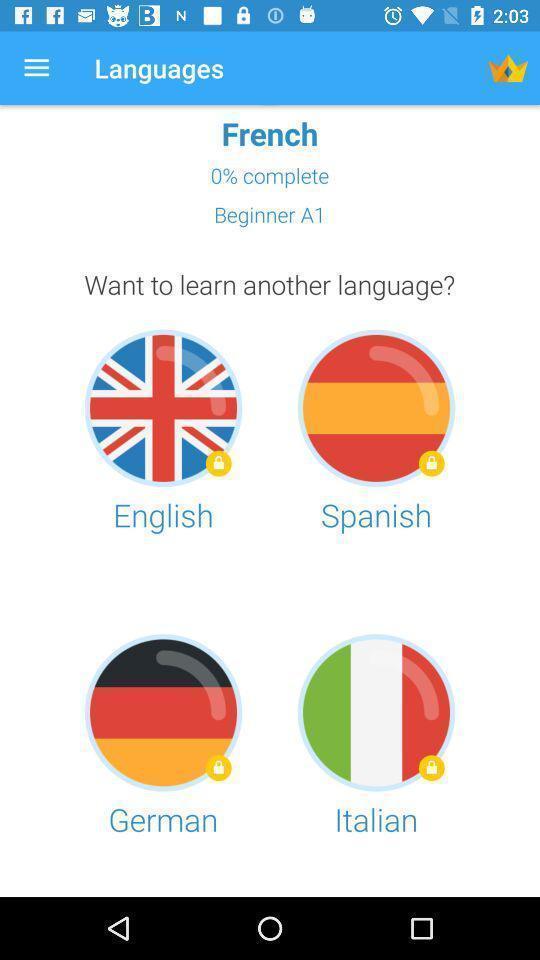Summarize the information in this screenshot. Page that displaying language learning application. 